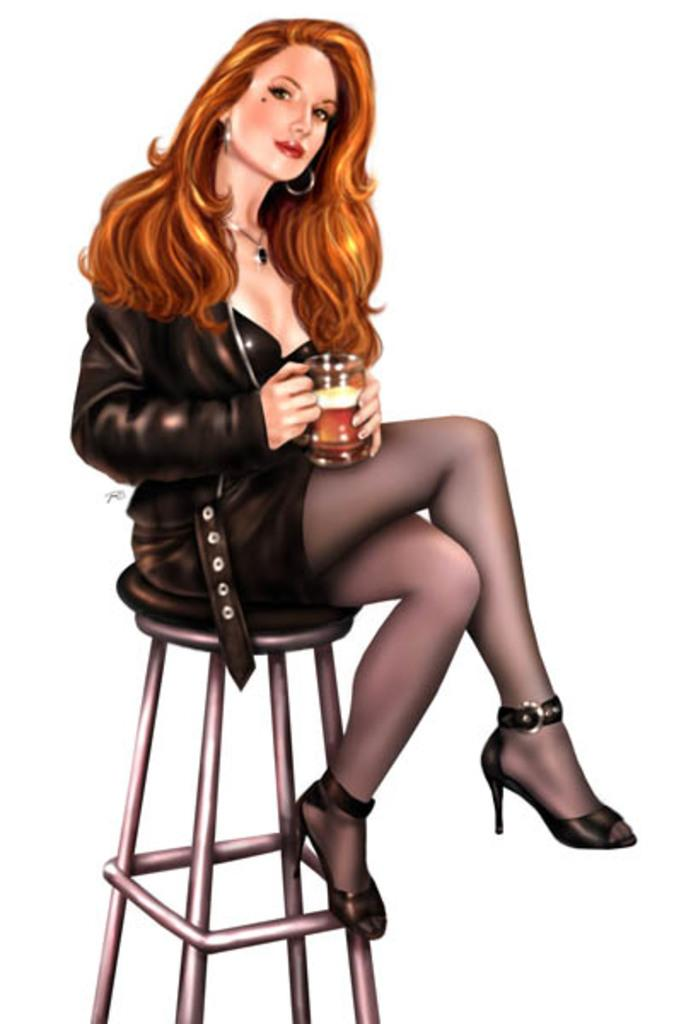Who is the main subject in the image? There is a woman in the image. What is the woman doing in the image? The woman is sitting on a chair. What is the woman holding in the image? The woman is holding a mug. What type of goat can be seen in the image? There is no goat present in the image. What adjustments does the woman make to her chair in the image? The image does not show any adjustments being made to the chair. 